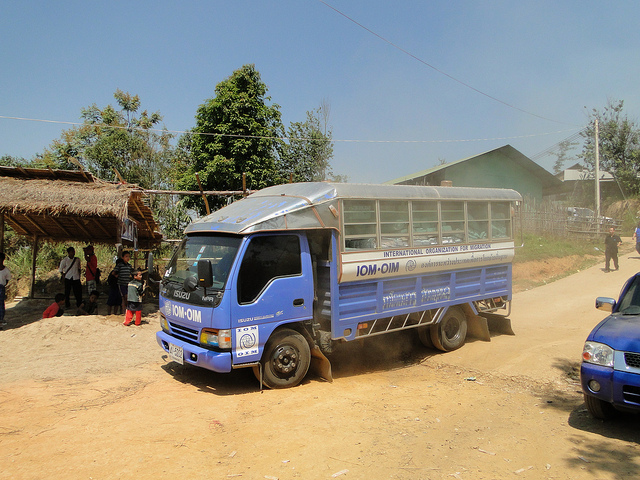Identify the text displayed in this image. IOM.OIM IOM.OIM INTERNATIONAL ORGANIZATION OIM GURU 